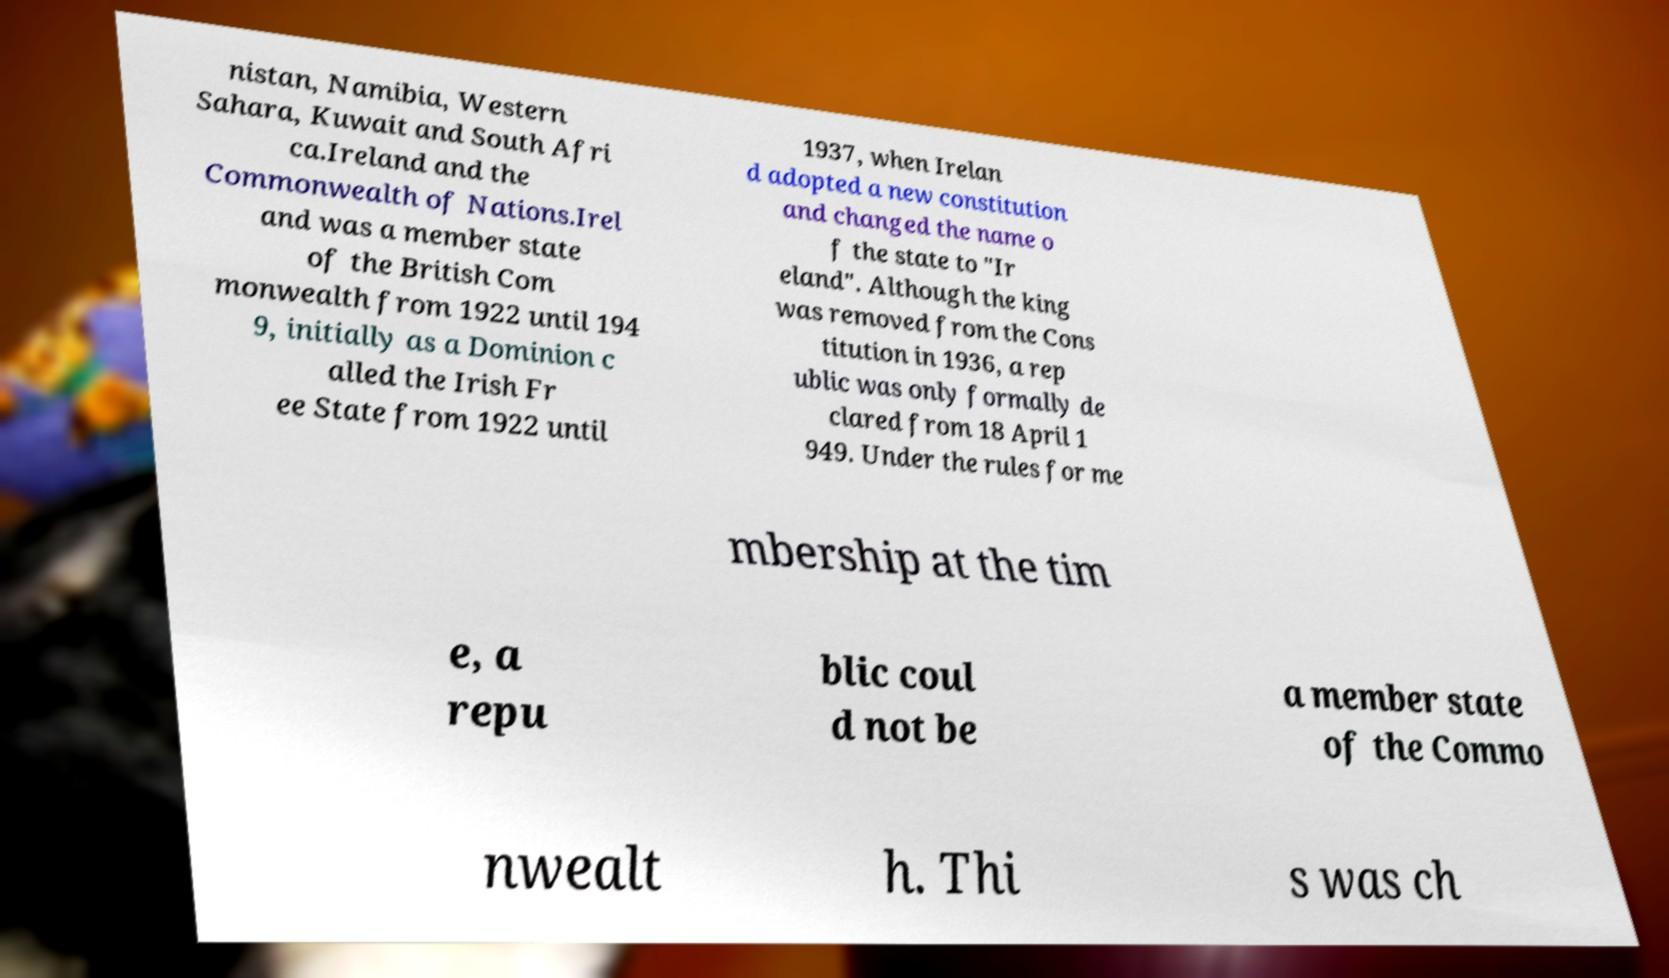I need the written content from this picture converted into text. Can you do that? nistan, Namibia, Western Sahara, Kuwait and South Afri ca.Ireland and the Commonwealth of Nations.Irel and was a member state of the British Com monwealth from 1922 until 194 9, initially as a Dominion c alled the Irish Fr ee State from 1922 until 1937, when Irelan d adopted a new constitution and changed the name o f the state to "Ir eland". Although the king was removed from the Cons titution in 1936, a rep ublic was only formally de clared from 18 April 1 949. Under the rules for me mbership at the tim e, a repu blic coul d not be a member state of the Commo nwealt h. Thi s was ch 